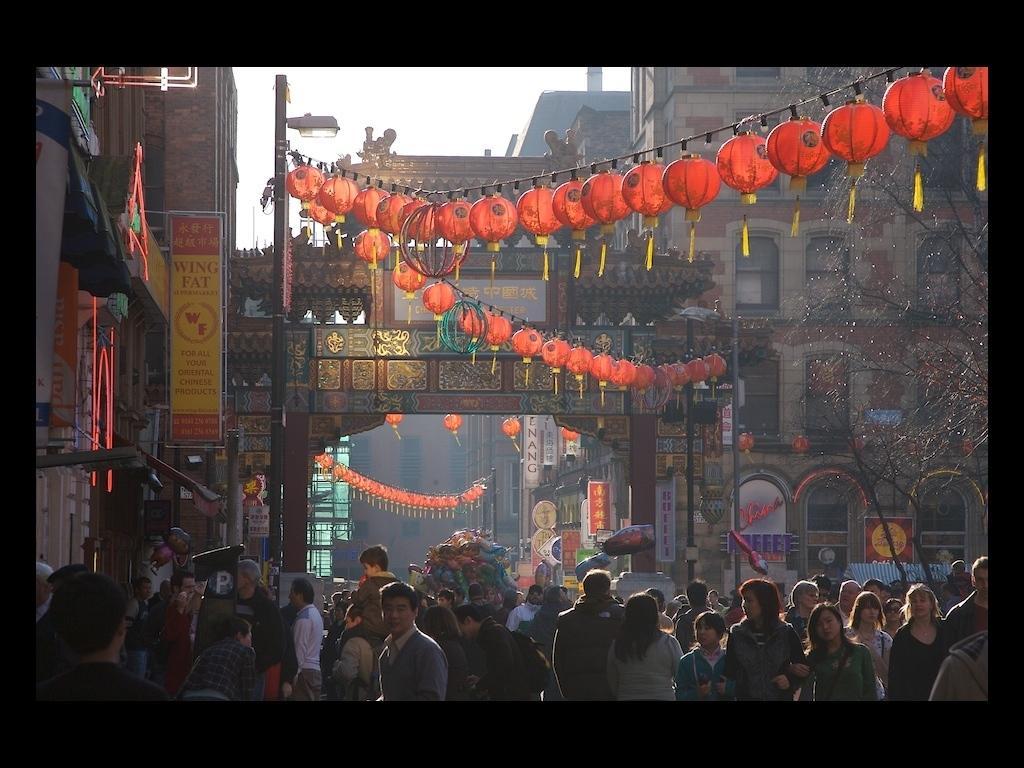In one or two sentences, can you explain what this image depicts? In this image I can see group of people some are standing and some are walking, I can also see few stalls and few boards attached to the building. Background I can see few buildings in brown, cream color. I can see few light balls in orange color, a light pole. Background the sky is in white color. 